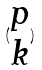<formula> <loc_0><loc_0><loc_500><loc_500>( \begin{matrix} p \\ k \end{matrix} )</formula> 